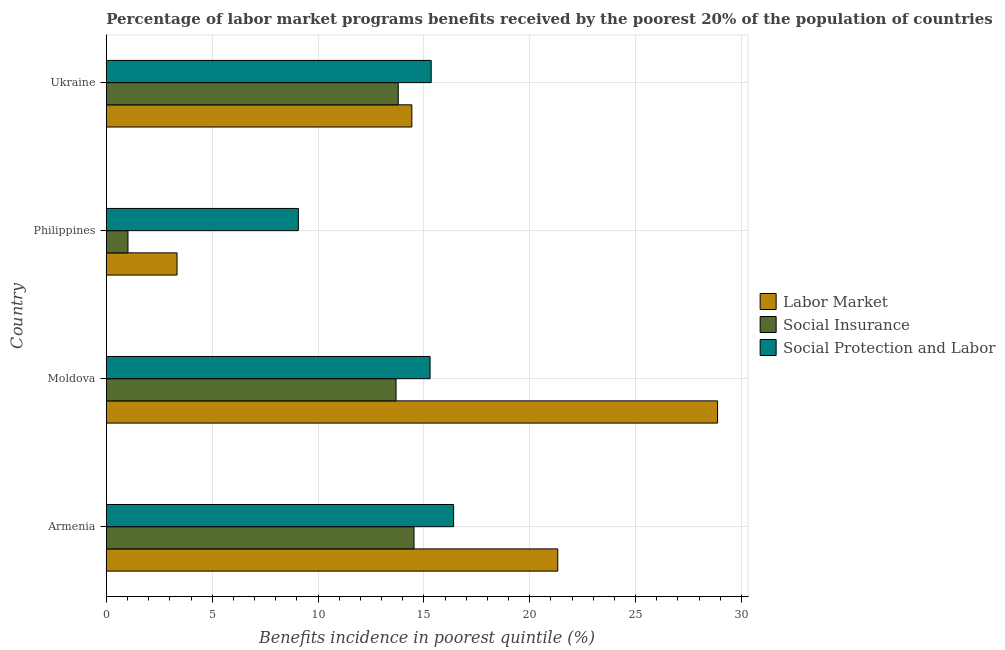How many different coloured bars are there?
Offer a very short reply. 3. How many groups of bars are there?
Keep it short and to the point. 4. Are the number of bars on each tick of the Y-axis equal?
Your response must be concise. Yes. How many bars are there on the 3rd tick from the top?
Keep it short and to the point. 3. What is the label of the 3rd group of bars from the top?
Your answer should be compact. Moldova. In how many cases, is the number of bars for a given country not equal to the number of legend labels?
Your answer should be very brief. 0. What is the percentage of benefits received due to social protection programs in Philippines?
Provide a succinct answer. 9.07. Across all countries, what is the maximum percentage of benefits received due to social insurance programs?
Give a very brief answer. 14.54. Across all countries, what is the minimum percentage of benefits received due to labor market programs?
Keep it short and to the point. 3.34. In which country was the percentage of benefits received due to social insurance programs maximum?
Your answer should be very brief. Armenia. What is the total percentage of benefits received due to labor market programs in the graph?
Give a very brief answer. 67.97. What is the difference between the percentage of benefits received due to labor market programs in Moldova and that in Philippines?
Your response must be concise. 25.54. What is the difference between the percentage of benefits received due to social protection programs in Moldova and the percentage of benefits received due to social insurance programs in Ukraine?
Offer a very short reply. 1.5. What is the average percentage of benefits received due to social insurance programs per country?
Keep it short and to the point. 10.76. What is the difference between the percentage of benefits received due to social protection programs and percentage of benefits received due to social insurance programs in Philippines?
Your response must be concise. 8.05. What is the ratio of the percentage of benefits received due to labor market programs in Armenia to that in Ukraine?
Ensure brevity in your answer.  1.48. Is the percentage of benefits received due to labor market programs in Moldova less than that in Philippines?
Your answer should be compact. No. What is the difference between the highest and the second highest percentage of benefits received due to social insurance programs?
Keep it short and to the point. 0.74. What is the difference between the highest and the lowest percentage of benefits received due to social insurance programs?
Keep it short and to the point. 13.51. In how many countries, is the percentage of benefits received due to social protection programs greater than the average percentage of benefits received due to social protection programs taken over all countries?
Provide a succinct answer. 3. Is the sum of the percentage of benefits received due to labor market programs in Moldova and Philippines greater than the maximum percentage of benefits received due to social insurance programs across all countries?
Offer a terse response. Yes. What does the 2nd bar from the top in Armenia represents?
Provide a short and direct response. Social Insurance. What does the 1st bar from the bottom in Moldova represents?
Offer a very short reply. Labor Market. Is it the case that in every country, the sum of the percentage of benefits received due to labor market programs and percentage of benefits received due to social insurance programs is greater than the percentage of benefits received due to social protection programs?
Give a very brief answer. No. Are all the bars in the graph horizontal?
Keep it short and to the point. Yes. Are the values on the major ticks of X-axis written in scientific E-notation?
Your response must be concise. No. What is the title of the graph?
Your answer should be very brief. Percentage of labor market programs benefits received by the poorest 20% of the population of countries. What is the label or title of the X-axis?
Give a very brief answer. Benefits incidence in poorest quintile (%). What is the label or title of the Y-axis?
Provide a short and direct response. Country. What is the Benefits incidence in poorest quintile (%) in Labor Market in Armenia?
Make the answer very short. 21.33. What is the Benefits incidence in poorest quintile (%) in Social Insurance in Armenia?
Ensure brevity in your answer.  14.54. What is the Benefits incidence in poorest quintile (%) of Social Protection and Labor in Armenia?
Provide a succinct answer. 16.41. What is the Benefits incidence in poorest quintile (%) of Labor Market in Moldova?
Your answer should be compact. 28.88. What is the Benefits incidence in poorest quintile (%) of Social Insurance in Moldova?
Your response must be concise. 13.69. What is the Benefits incidence in poorest quintile (%) in Social Protection and Labor in Moldova?
Your answer should be very brief. 15.29. What is the Benefits incidence in poorest quintile (%) in Labor Market in Philippines?
Your answer should be very brief. 3.34. What is the Benefits incidence in poorest quintile (%) in Social Insurance in Philippines?
Offer a very short reply. 1.02. What is the Benefits incidence in poorest quintile (%) in Social Protection and Labor in Philippines?
Provide a short and direct response. 9.07. What is the Benefits incidence in poorest quintile (%) in Labor Market in Ukraine?
Ensure brevity in your answer.  14.43. What is the Benefits incidence in poorest quintile (%) in Social Insurance in Ukraine?
Your answer should be very brief. 13.79. What is the Benefits incidence in poorest quintile (%) in Social Protection and Labor in Ukraine?
Provide a short and direct response. 15.35. Across all countries, what is the maximum Benefits incidence in poorest quintile (%) of Labor Market?
Your response must be concise. 28.88. Across all countries, what is the maximum Benefits incidence in poorest quintile (%) of Social Insurance?
Your answer should be very brief. 14.54. Across all countries, what is the maximum Benefits incidence in poorest quintile (%) of Social Protection and Labor?
Make the answer very short. 16.41. Across all countries, what is the minimum Benefits incidence in poorest quintile (%) in Labor Market?
Your response must be concise. 3.34. Across all countries, what is the minimum Benefits incidence in poorest quintile (%) of Social Insurance?
Your response must be concise. 1.02. Across all countries, what is the minimum Benefits incidence in poorest quintile (%) in Social Protection and Labor?
Offer a very short reply. 9.07. What is the total Benefits incidence in poorest quintile (%) of Labor Market in the graph?
Your answer should be compact. 67.97. What is the total Benefits incidence in poorest quintile (%) in Social Insurance in the graph?
Ensure brevity in your answer.  43.03. What is the total Benefits incidence in poorest quintile (%) in Social Protection and Labor in the graph?
Provide a succinct answer. 56.12. What is the difference between the Benefits incidence in poorest quintile (%) of Labor Market in Armenia and that in Moldova?
Make the answer very short. -7.55. What is the difference between the Benefits incidence in poorest quintile (%) in Social Insurance in Armenia and that in Moldova?
Provide a short and direct response. 0.85. What is the difference between the Benefits incidence in poorest quintile (%) of Social Protection and Labor in Armenia and that in Moldova?
Make the answer very short. 1.11. What is the difference between the Benefits incidence in poorest quintile (%) of Labor Market in Armenia and that in Philippines?
Your response must be concise. 17.99. What is the difference between the Benefits incidence in poorest quintile (%) in Social Insurance in Armenia and that in Philippines?
Offer a very short reply. 13.51. What is the difference between the Benefits incidence in poorest quintile (%) of Social Protection and Labor in Armenia and that in Philippines?
Keep it short and to the point. 7.34. What is the difference between the Benefits incidence in poorest quintile (%) of Labor Market in Armenia and that in Ukraine?
Give a very brief answer. 6.89. What is the difference between the Benefits incidence in poorest quintile (%) in Social Insurance in Armenia and that in Ukraine?
Give a very brief answer. 0.74. What is the difference between the Benefits incidence in poorest quintile (%) of Social Protection and Labor in Armenia and that in Ukraine?
Offer a very short reply. 1.06. What is the difference between the Benefits incidence in poorest quintile (%) in Labor Market in Moldova and that in Philippines?
Provide a short and direct response. 25.54. What is the difference between the Benefits incidence in poorest quintile (%) in Social Insurance in Moldova and that in Philippines?
Keep it short and to the point. 12.66. What is the difference between the Benefits incidence in poorest quintile (%) of Social Protection and Labor in Moldova and that in Philippines?
Your answer should be compact. 6.22. What is the difference between the Benefits incidence in poorest quintile (%) in Labor Market in Moldova and that in Ukraine?
Your answer should be very brief. 14.44. What is the difference between the Benefits incidence in poorest quintile (%) in Social Insurance in Moldova and that in Ukraine?
Ensure brevity in your answer.  -0.1. What is the difference between the Benefits incidence in poorest quintile (%) of Social Protection and Labor in Moldova and that in Ukraine?
Make the answer very short. -0.05. What is the difference between the Benefits incidence in poorest quintile (%) of Labor Market in Philippines and that in Ukraine?
Make the answer very short. -11.09. What is the difference between the Benefits incidence in poorest quintile (%) in Social Insurance in Philippines and that in Ukraine?
Your response must be concise. -12.77. What is the difference between the Benefits incidence in poorest quintile (%) in Social Protection and Labor in Philippines and that in Ukraine?
Provide a succinct answer. -6.28. What is the difference between the Benefits incidence in poorest quintile (%) in Labor Market in Armenia and the Benefits incidence in poorest quintile (%) in Social Insurance in Moldova?
Make the answer very short. 7.64. What is the difference between the Benefits incidence in poorest quintile (%) of Labor Market in Armenia and the Benefits incidence in poorest quintile (%) of Social Protection and Labor in Moldova?
Provide a succinct answer. 6.03. What is the difference between the Benefits incidence in poorest quintile (%) in Social Insurance in Armenia and the Benefits incidence in poorest quintile (%) in Social Protection and Labor in Moldova?
Your answer should be very brief. -0.76. What is the difference between the Benefits incidence in poorest quintile (%) in Labor Market in Armenia and the Benefits incidence in poorest quintile (%) in Social Insurance in Philippines?
Your answer should be compact. 20.3. What is the difference between the Benefits incidence in poorest quintile (%) of Labor Market in Armenia and the Benefits incidence in poorest quintile (%) of Social Protection and Labor in Philippines?
Offer a terse response. 12.25. What is the difference between the Benefits incidence in poorest quintile (%) in Social Insurance in Armenia and the Benefits incidence in poorest quintile (%) in Social Protection and Labor in Philippines?
Your response must be concise. 5.46. What is the difference between the Benefits incidence in poorest quintile (%) in Labor Market in Armenia and the Benefits incidence in poorest quintile (%) in Social Insurance in Ukraine?
Provide a short and direct response. 7.53. What is the difference between the Benefits incidence in poorest quintile (%) in Labor Market in Armenia and the Benefits incidence in poorest quintile (%) in Social Protection and Labor in Ukraine?
Your response must be concise. 5.98. What is the difference between the Benefits incidence in poorest quintile (%) in Social Insurance in Armenia and the Benefits incidence in poorest quintile (%) in Social Protection and Labor in Ukraine?
Provide a short and direct response. -0.81. What is the difference between the Benefits incidence in poorest quintile (%) of Labor Market in Moldova and the Benefits incidence in poorest quintile (%) of Social Insurance in Philippines?
Make the answer very short. 27.85. What is the difference between the Benefits incidence in poorest quintile (%) of Labor Market in Moldova and the Benefits incidence in poorest quintile (%) of Social Protection and Labor in Philippines?
Offer a very short reply. 19.8. What is the difference between the Benefits incidence in poorest quintile (%) of Social Insurance in Moldova and the Benefits incidence in poorest quintile (%) of Social Protection and Labor in Philippines?
Your response must be concise. 4.62. What is the difference between the Benefits incidence in poorest quintile (%) in Labor Market in Moldova and the Benefits incidence in poorest quintile (%) in Social Insurance in Ukraine?
Give a very brief answer. 15.09. What is the difference between the Benefits incidence in poorest quintile (%) of Labor Market in Moldova and the Benefits incidence in poorest quintile (%) of Social Protection and Labor in Ukraine?
Offer a terse response. 13.53. What is the difference between the Benefits incidence in poorest quintile (%) in Social Insurance in Moldova and the Benefits incidence in poorest quintile (%) in Social Protection and Labor in Ukraine?
Ensure brevity in your answer.  -1.66. What is the difference between the Benefits incidence in poorest quintile (%) in Labor Market in Philippines and the Benefits incidence in poorest quintile (%) in Social Insurance in Ukraine?
Offer a very short reply. -10.45. What is the difference between the Benefits incidence in poorest quintile (%) in Labor Market in Philippines and the Benefits incidence in poorest quintile (%) in Social Protection and Labor in Ukraine?
Keep it short and to the point. -12.01. What is the difference between the Benefits incidence in poorest quintile (%) in Social Insurance in Philippines and the Benefits incidence in poorest quintile (%) in Social Protection and Labor in Ukraine?
Provide a short and direct response. -14.32. What is the average Benefits incidence in poorest quintile (%) in Labor Market per country?
Offer a terse response. 16.99. What is the average Benefits incidence in poorest quintile (%) of Social Insurance per country?
Ensure brevity in your answer.  10.76. What is the average Benefits incidence in poorest quintile (%) in Social Protection and Labor per country?
Keep it short and to the point. 14.03. What is the difference between the Benefits incidence in poorest quintile (%) in Labor Market and Benefits incidence in poorest quintile (%) in Social Insurance in Armenia?
Make the answer very short. 6.79. What is the difference between the Benefits incidence in poorest quintile (%) in Labor Market and Benefits incidence in poorest quintile (%) in Social Protection and Labor in Armenia?
Your response must be concise. 4.92. What is the difference between the Benefits incidence in poorest quintile (%) in Social Insurance and Benefits incidence in poorest quintile (%) in Social Protection and Labor in Armenia?
Your response must be concise. -1.87. What is the difference between the Benefits incidence in poorest quintile (%) of Labor Market and Benefits incidence in poorest quintile (%) of Social Insurance in Moldova?
Keep it short and to the point. 15.19. What is the difference between the Benefits incidence in poorest quintile (%) in Labor Market and Benefits incidence in poorest quintile (%) in Social Protection and Labor in Moldova?
Offer a terse response. 13.58. What is the difference between the Benefits incidence in poorest quintile (%) in Social Insurance and Benefits incidence in poorest quintile (%) in Social Protection and Labor in Moldova?
Keep it short and to the point. -1.61. What is the difference between the Benefits incidence in poorest quintile (%) in Labor Market and Benefits incidence in poorest quintile (%) in Social Insurance in Philippines?
Offer a very short reply. 2.32. What is the difference between the Benefits incidence in poorest quintile (%) of Labor Market and Benefits incidence in poorest quintile (%) of Social Protection and Labor in Philippines?
Offer a very short reply. -5.73. What is the difference between the Benefits incidence in poorest quintile (%) in Social Insurance and Benefits incidence in poorest quintile (%) in Social Protection and Labor in Philippines?
Give a very brief answer. -8.05. What is the difference between the Benefits incidence in poorest quintile (%) in Labor Market and Benefits incidence in poorest quintile (%) in Social Insurance in Ukraine?
Make the answer very short. 0.64. What is the difference between the Benefits incidence in poorest quintile (%) in Labor Market and Benefits incidence in poorest quintile (%) in Social Protection and Labor in Ukraine?
Keep it short and to the point. -0.91. What is the difference between the Benefits incidence in poorest quintile (%) of Social Insurance and Benefits incidence in poorest quintile (%) of Social Protection and Labor in Ukraine?
Your answer should be compact. -1.56. What is the ratio of the Benefits incidence in poorest quintile (%) in Labor Market in Armenia to that in Moldova?
Offer a terse response. 0.74. What is the ratio of the Benefits incidence in poorest quintile (%) in Social Insurance in Armenia to that in Moldova?
Your answer should be compact. 1.06. What is the ratio of the Benefits incidence in poorest quintile (%) in Social Protection and Labor in Armenia to that in Moldova?
Provide a succinct answer. 1.07. What is the ratio of the Benefits incidence in poorest quintile (%) of Labor Market in Armenia to that in Philippines?
Make the answer very short. 6.38. What is the ratio of the Benefits incidence in poorest quintile (%) in Social Insurance in Armenia to that in Philippines?
Your response must be concise. 14.22. What is the ratio of the Benefits incidence in poorest quintile (%) in Social Protection and Labor in Armenia to that in Philippines?
Your answer should be compact. 1.81. What is the ratio of the Benefits incidence in poorest quintile (%) of Labor Market in Armenia to that in Ukraine?
Your response must be concise. 1.48. What is the ratio of the Benefits incidence in poorest quintile (%) in Social Insurance in Armenia to that in Ukraine?
Your answer should be compact. 1.05. What is the ratio of the Benefits incidence in poorest quintile (%) in Social Protection and Labor in Armenia to that in Ukraine?
Provide a succinct answer. 1.07. What is the ratio of the Benefits incidence in poorest quintile (%) in Labor Market in Moldova to that in Philippines?
Provide a succinct answer. 8.64. What is the ratio of the Benefits incidence in poorest quintile (%) of Social Insurance in Moldova to that in Philippines?
Give a very brief answer. 13.39. What is the ratio of the Benefits incidence in poorest quintile (%) in Social Protection and Labor in Moldova to that in Philippines?
Your response must be concise. 1.69. What is the ratio of the Benefits incidence in poorest quintile (%) of Labor Market in Moldova to that in Ukraine?
Offer a very short reply. 2. What is the ratio of the Benefits incidence in poorest quintile (%) in Labor Market in Philippines to that in Ukraine?
Keep it short and to the point. 0.23. What is the ratio of the Benefits incidence in poorest quintile (%) of Social Insurance in Philippines to that in Ukraine?
Make the answer very short. 0.07. What is the ratio of the Benefits incidence in poorest quintile (%) in Social Protection and Labor in Philippines to that in Ukraine?
Provide a succinct answer. 0.59. What is the difference between the highest and the second highest Benefits incidence in poorest quintile (%) in Labor Market?
Ensure brevity in your answer.  7.55. What is the difference between the highest and the second highest Benefits incidence in poorest quintile (%) in Social Insurance?
Provide a succinct answer. 0.74. What is the difference between the highest and the second highest Benefits incidence in poorest quintile (%) of Social Protection and Labor?
Your answer should be compact. 1.06. What is the difference between the highest and the lowest Benefits incidence in poorest quintile (%) in Labor Market?
Provide a short and direct response. 25.54. What is the difference between the highest and the lowest Benefits incidence in poorest quintile (%) of Social Insurance?
Ensure brevity in your answer.  13.51. What is the difference between the highest and the lowest Benefits incidence in poorest quintile (%) in Social Protection and Labor?
Provide a succinct answer. 7.34. 